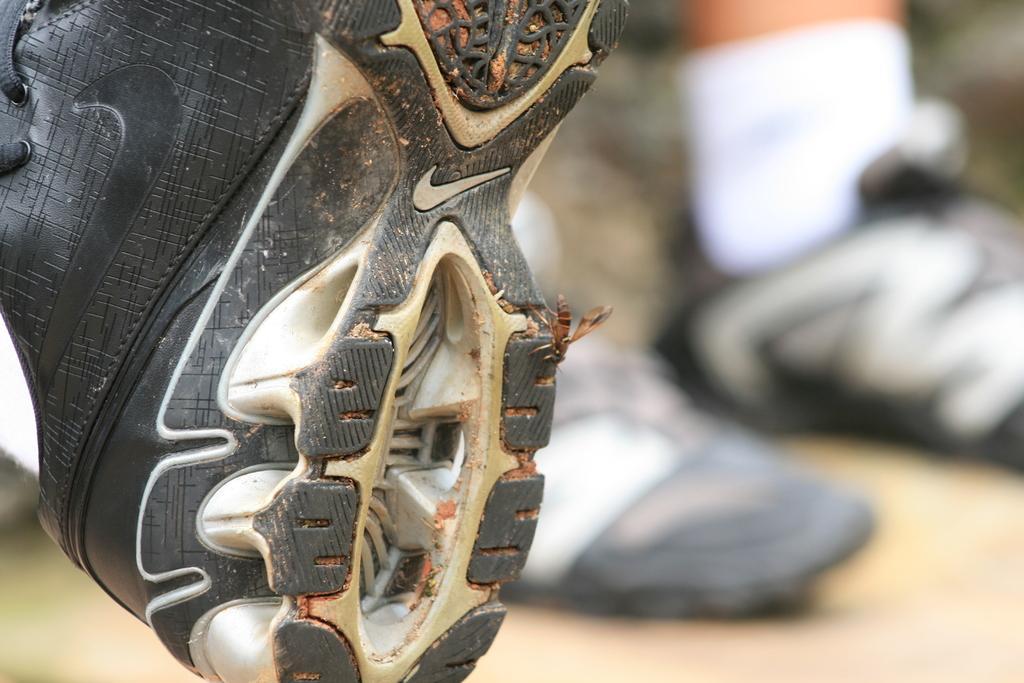Please provide a concise description of this image. In this picture we can see a shoe and in the background we can see a person leg with a sock and shoes on the ground and it is blurry. 